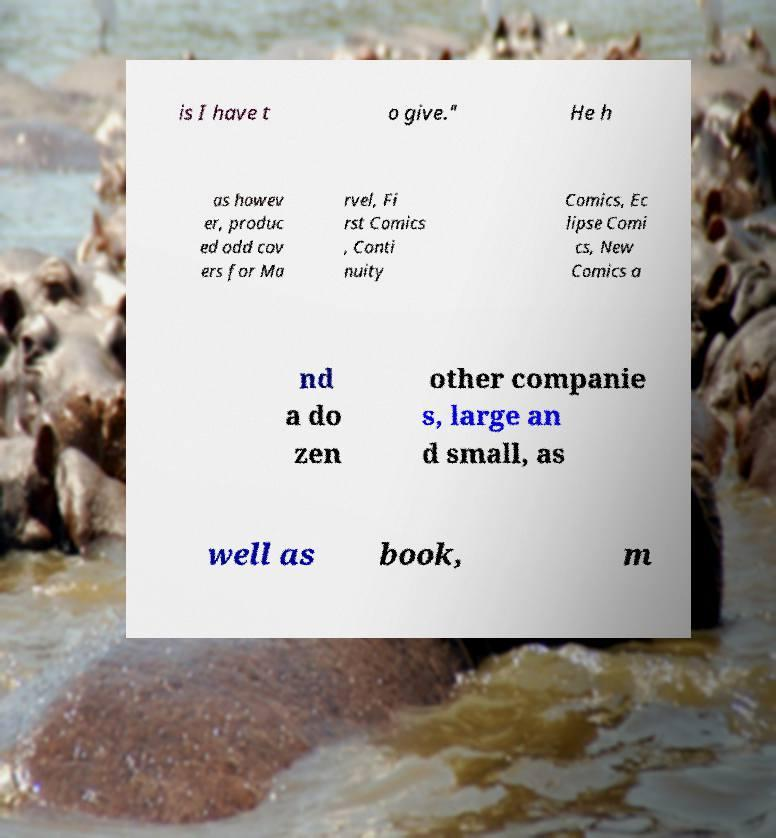Please read and relay the text visible in this image. What does it say? is I have t o give." He h as howev er, produc ed odd cov ers for Ma rvel, Fi rst Comics , Conti nuity Comics, Ec lipse Comi cs, New Comics a nd a do zen other companie s, large an d small, as well as book, m 